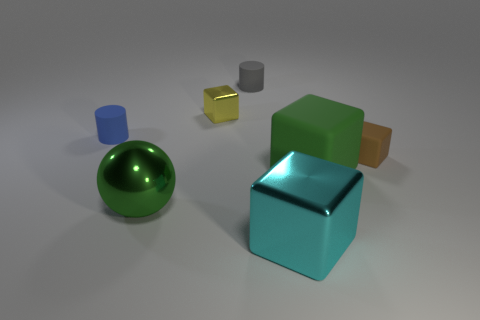Add 2 green shiny things. How many objects exist? 9 Subtract all cubes. How many objects are left? 3 Add 4 matte objects. How many matte objects are left? 8 Add 3 yellow shiny cylinders. How many yellow shiny cylinders exist? 3 Subtract 0 gray spheres. How many objects are left? 7 Subtract all big cyan things. Subtract all cyan shiny objects. How many objects are left? 5 